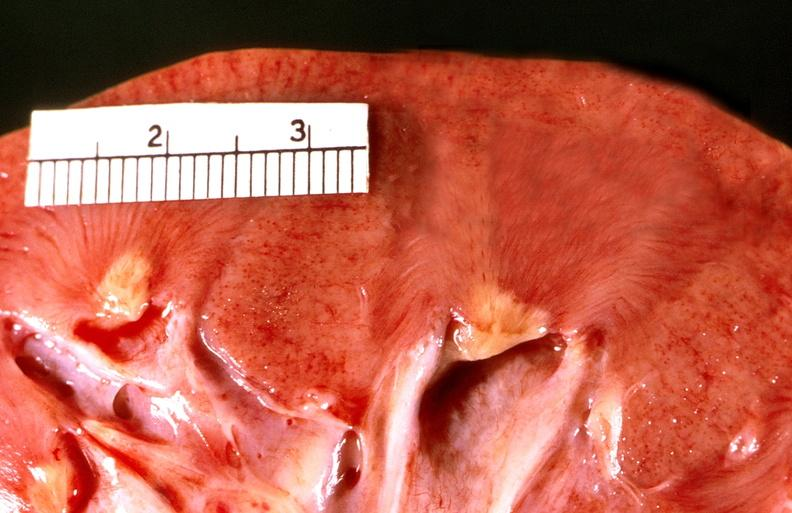does this image show renal papillary necrosis, diabetes mellitus dm?
Answer the question using a single word or phrase. Yes 